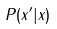<formula> <loc_0><loc_0><loc_500><loc_500>P ( x ^ { \prime } | x )</formula> 